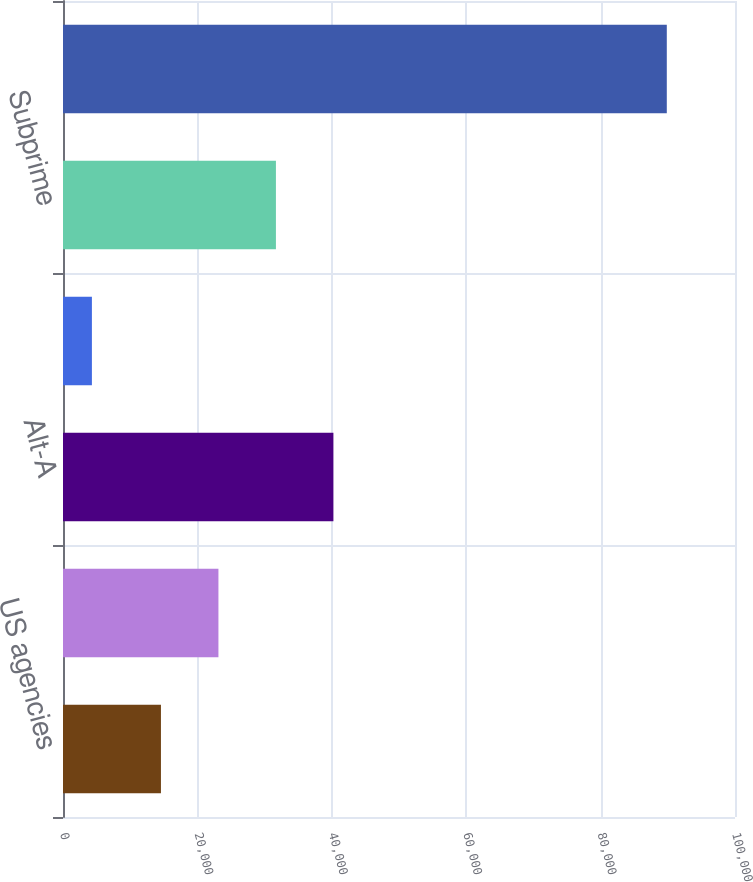Convert chart. <chart><loc_0><loc_0><loc_500><loc_500><bar_chart><fcel>US agencies<fcel>Prime non-agency (a)<fcel>Alt-A<fcel>Other housing-related (b)<fcel>Subprime<fcel>Total<nl><fcel>14575<fcel>23130<fcel>40240<fcel>4301<fcel>31685<fcel>89851<nl></chart> 